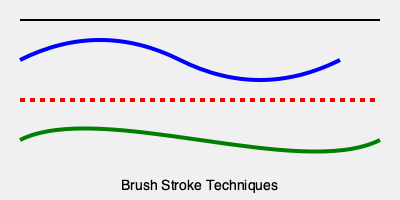Which brush stroke technique, as shown in the diagram, is most effective for creating a sense of fluid motion and organic curves in a painting? To answer this question, let's analyze the three brush stroke techniques shown in the diagram:

1. The blue line at the top represents a smooth, wavelike stroke. This technique, known as the "S-curve" or "serpentine line," creates a flowing, graceful movement across the canvas. It's achieved by varying pressure and direction in a continuous motion.

2. The red dashed line in the middle shows a technique called "hatching" or "broken stroke." This method involves creating short, parallel lines or dashes. While it can add texture and rhythm to a painting, it doesn't inherently create a sense of fluid motion.

3. The green line at the bottom illustrates a "curved stroke" or "gestural line." This technique involves a sweeping, curvilinear motion that changes direction smoothly. It's characterized by its organic, free-flowing nature and ability to convey movement and energy.

Among these techniques, the curved stroke (green line) is most effective for creating a sense of fluid motion and organic curves. This is because:

a) It allows for continuous, unbroken lines that can follow the contours of a subject.
b) The varying thickness and direction of the stroke can suggest volume and dimension.
c) Its organic nature mimics natural forms and movements, enhancing the sense of fluidity in the painting.

While the S-curve (blue line) also creates a sense of motion, it's more controlled and rhythmic. The curved stroke offers more freedom and expressiveness, making it superior for conveying fluid, organic movement in a painting.
Answer: Curved stroke (green line) 